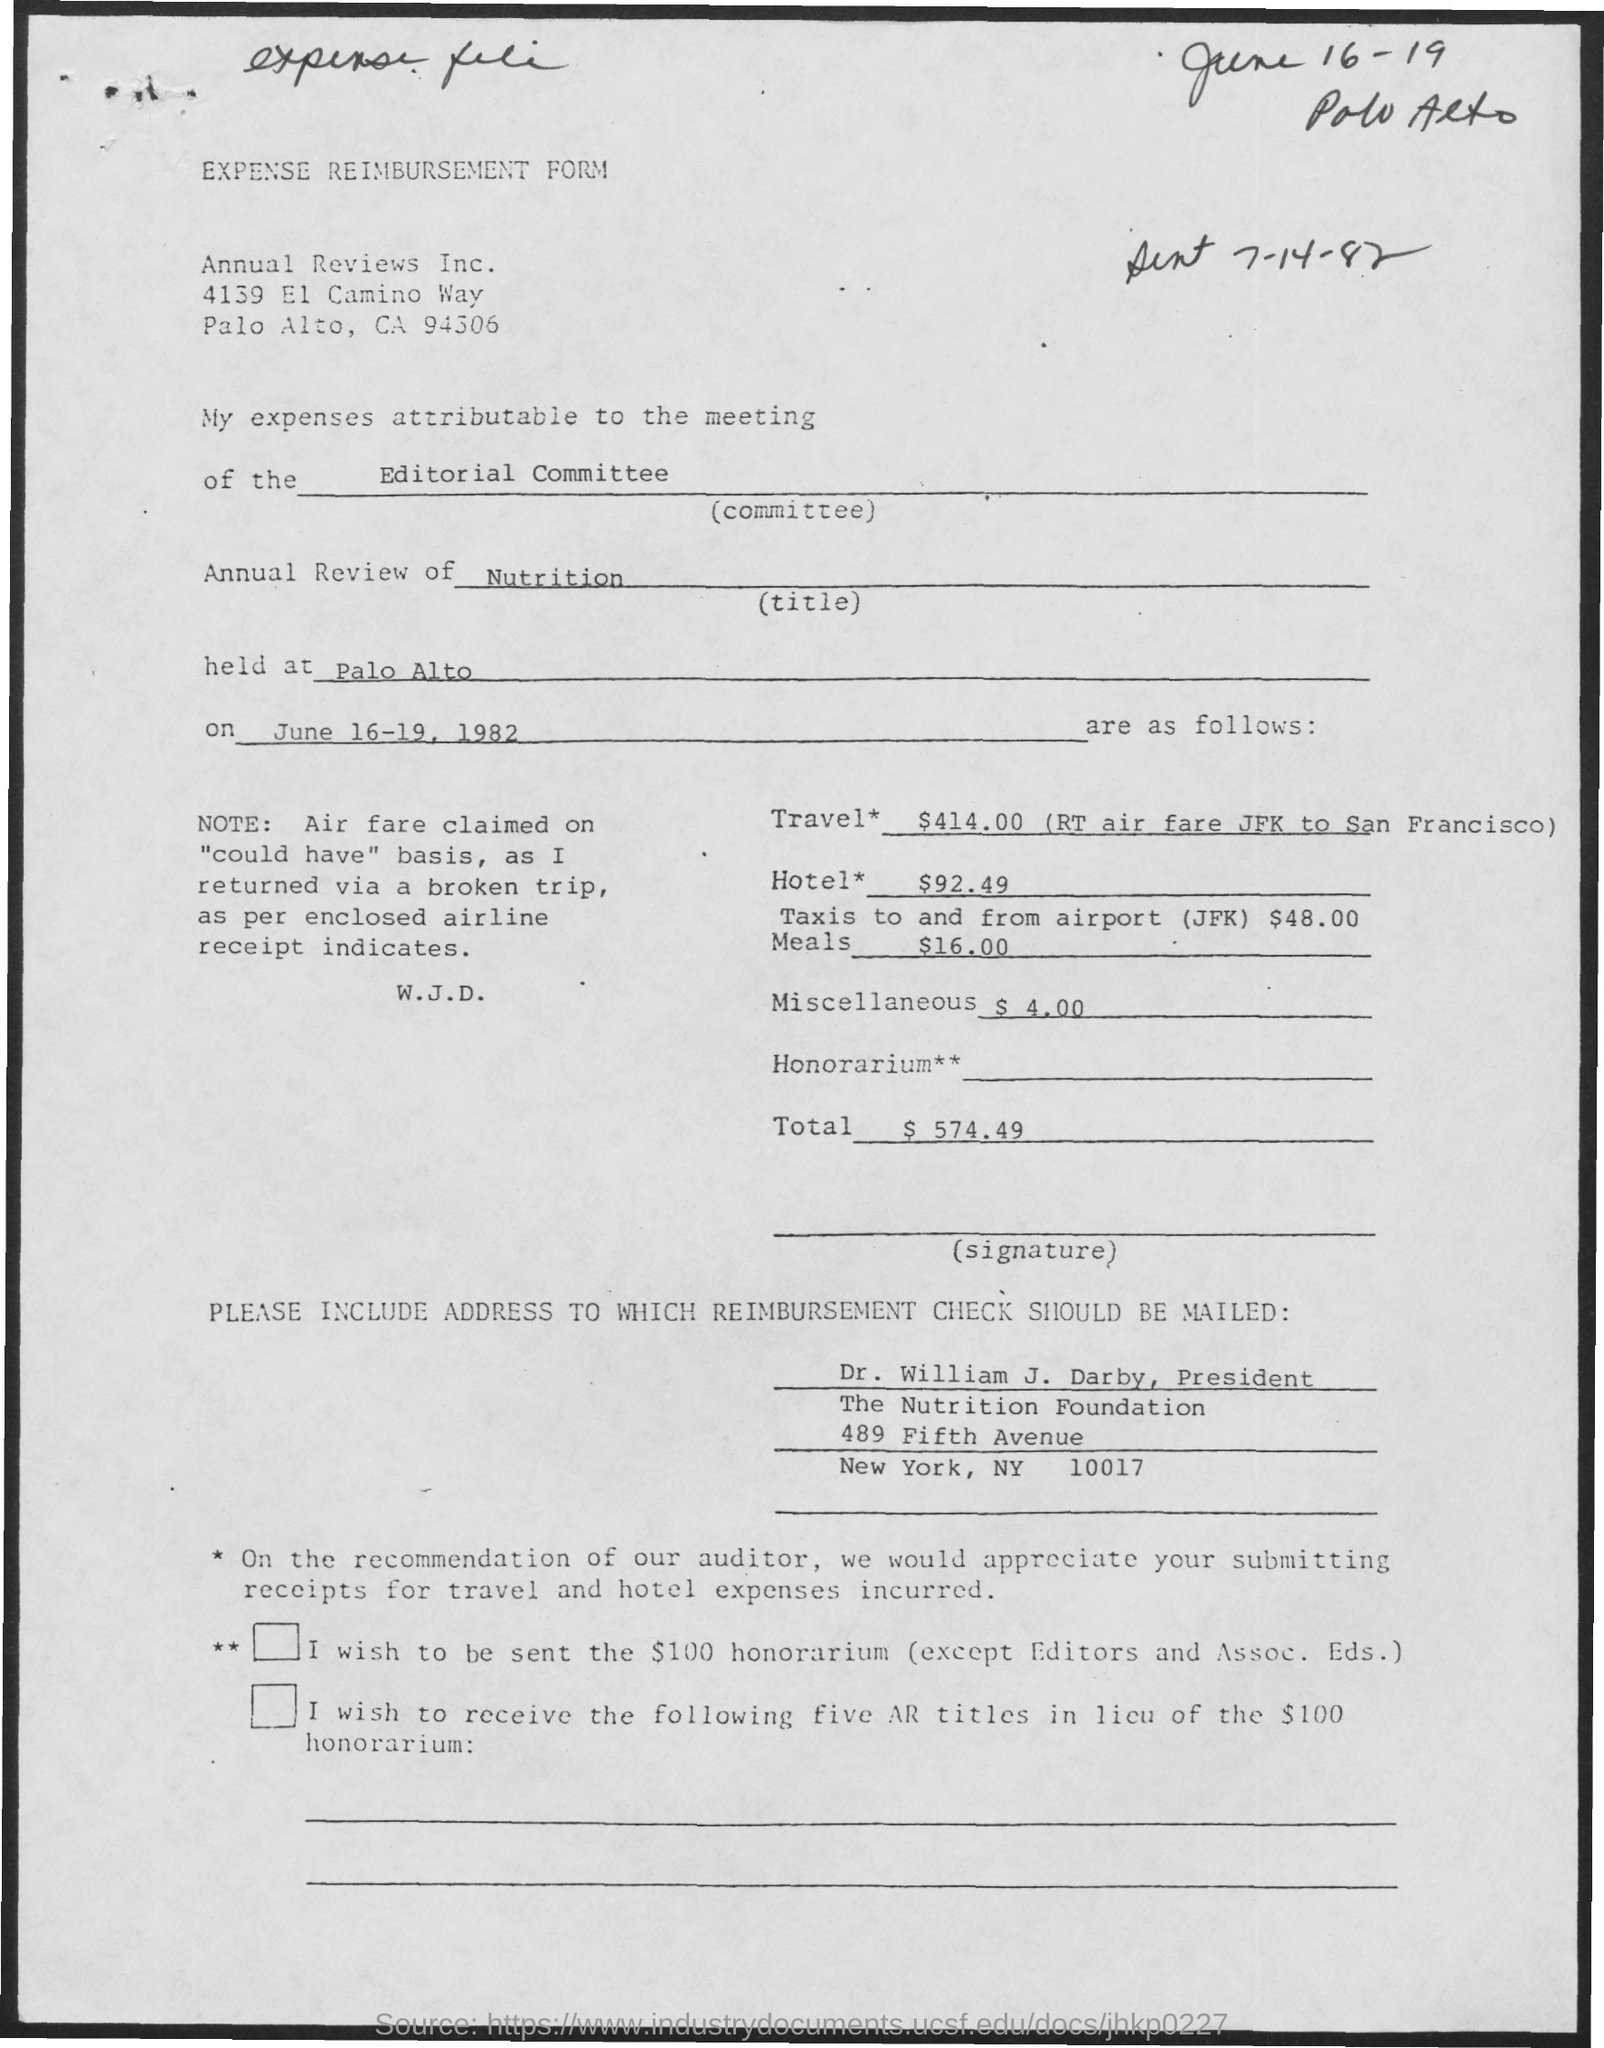What is the name of the form?
Provide a short and direct response. Expense Reimbursement form. What is annual review title?
Your answer should be compact. Nutrition. Where is this annual review held at?
Make the answer very short. Palo Alto. What is the expense for hotel* ?
Give a very brief answer. $92.49. Who is the president of the nutrition foundation?
Offer a very short reply. Dr. William J. Darby. What is total expense ?
Give a very brief answer. $ 574.49. 